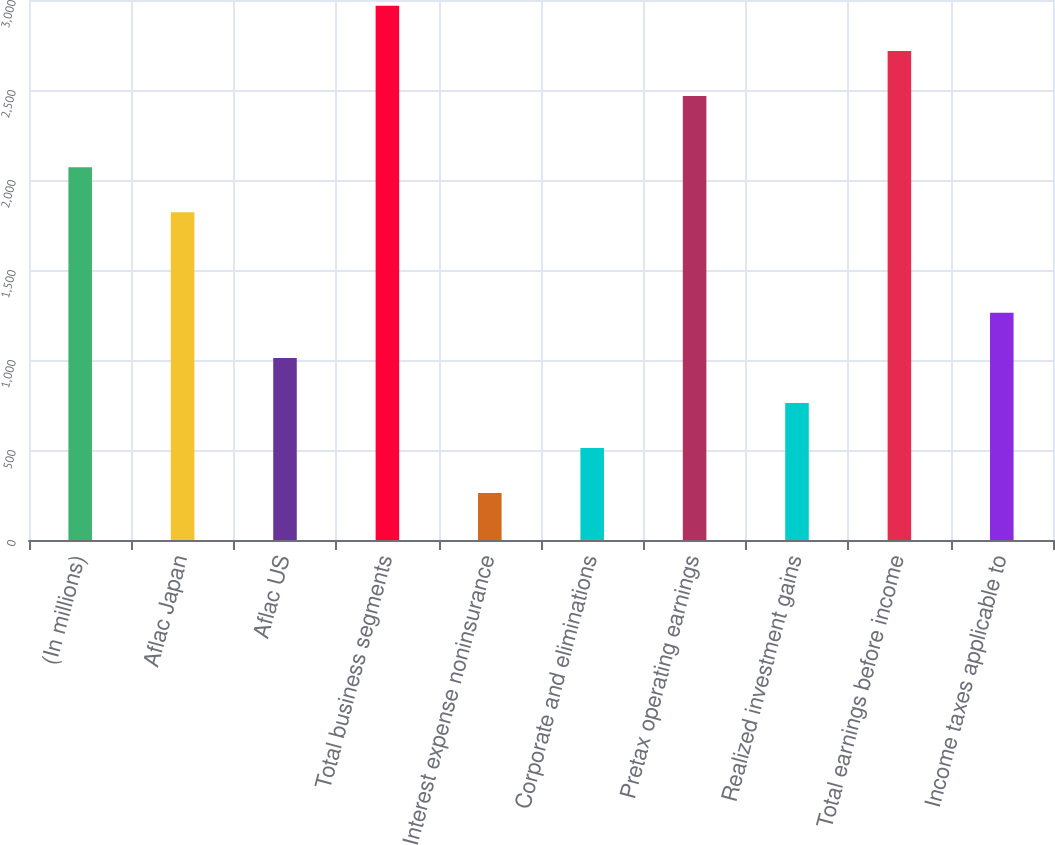Convert chart. <chart><loc_0><loc_0><loc_500><loc_500><bar_chart><fcel>(In millions)<fcel>Aflac Japan<fcel>Aflac US<fcel>Total business segments<fcel>Interest expense noninsurance<fcel>Corporate and eliminations<fcel>Pretax operating earnings<fcel>Realized investment gains<fcel>Total earnings before income<fcel>Income taxes applicable to<nl><fcel>2071.2<fcel>1821<fcel>1011.8<fcel>2967.4<fcel>261.2<fcel>511.4<fcel>2467<fcel>761.6<fcel>2717.2<fcel>1262<nl></chart> 